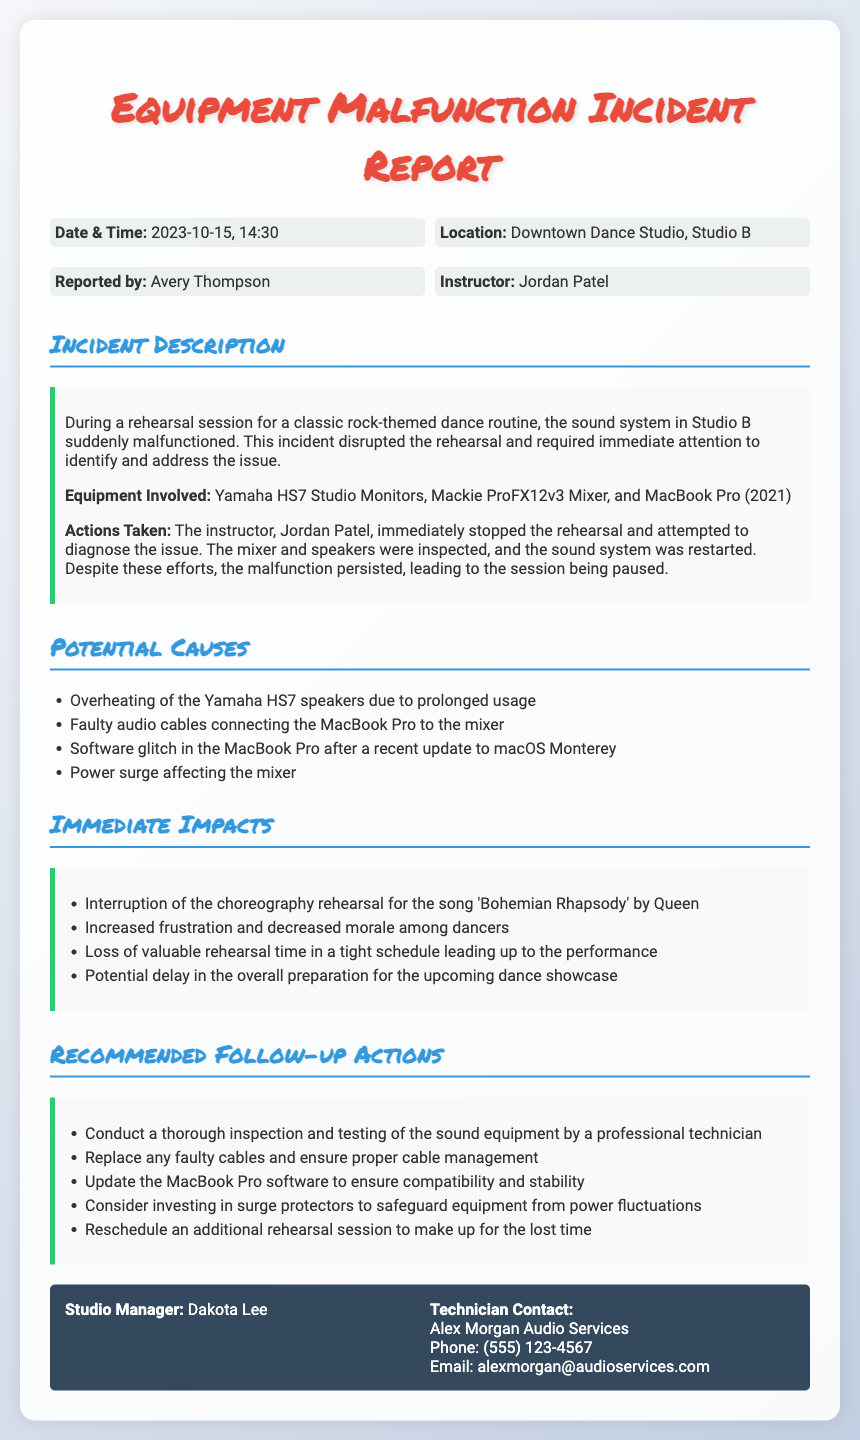what was the date of the incident? The date of the incident is clearly stated in the document as 2023-10-15.
Answer: 2023-10-15 who reported the incident? The document specifies that Avery Thompson reported the incident.
Answer: Avery Thompson what equipment was involved in the malfunction? The report lists the equipment involved as Yamaha HS7 Studio Monitors, Mackie ProFX12v3 Mixer, and MacBook Pro (2021).
Answer: Yamaha HS7 Studio Monitors, Mackie ProFX12v3 Mixer, and MacBook Pro (2021) what was one of the immediate impacts of the malfunction? The document notes several impacts; one is the interruption of the choreography rehearsal for 'Bohemian Rhapsody' by Queen.
Answer: Interruption of the choreography rehearsal for 'Bohemian Rhapsody' what is one potential cause for the sound system failure? Several potential causes are mentioned; one is overheating of the Yamaha HS7 speakers due to prolonged usage.
Answer: Overheating of the Yamaha HS7 speakers due to prolonged usage who is the studio manager? The contact information section indicates that Dakota Lee is the studio manager.
Answer: Dakota Lee what action was taken immediately after the malfunction? The instructor, Jordan Patel, stopped the rehearsal and attempted to diagnose the issue.
Answer: Jordan Patel stopped the rehearsal and attempted to diagnose the issue how many follow-up actions were recommended? There are a list of follow-up actions provided; the total number is five.
Answer: Five what was the time of the incident? The time listed in the document is 14:30.
Answer: 14:30 what is the technician's email address? The contact info provides Alex Morgan's email address as alexmorgan@audioservices.com.
Answer: alexmorgan@audioservices.com 